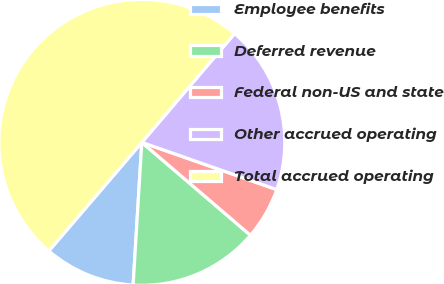Convert chart to OTSL. <chart><loc_0><loc_0><loc_500><loc_500><pie_chart><fcel>Employee benefits<fcel>Deferred revenue<fcel>Federal non-US and state<fcel>Other accrued operating<fcel>Total accrued operating<nl><fcel>10.3%<fcel>14.71%<fcel>5.9%<fcel>19.12%<fcel>49.97%<nl></chart> 